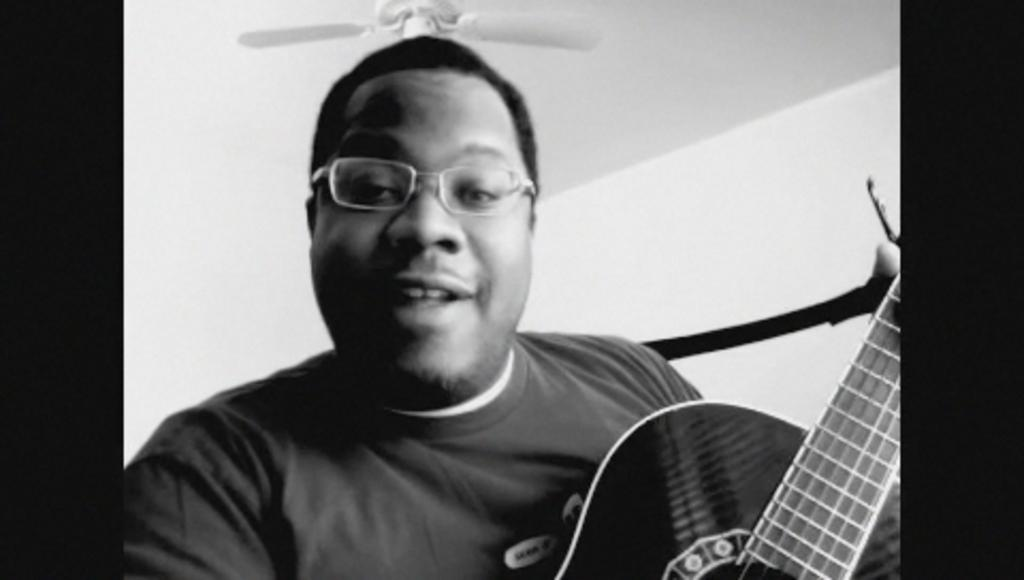What is the main subject of the image? The main subject of the image is a guy. What is the guy holding in the image? The guy is holding a guitar. Can you describe the guy's appearance in the image? The guy is wearing spectacles. What can be seen above the guy in the image? There is a fan visible above the guy. What type of vegetable is the guy eating in the image? There is no vegetable present in the image, and the guy is not eating anything. What is the guy doing while wearing his spectacles in the image? The guy is holding a guitar, but there is no indication of what he might be doing while wearing his spectacles. 